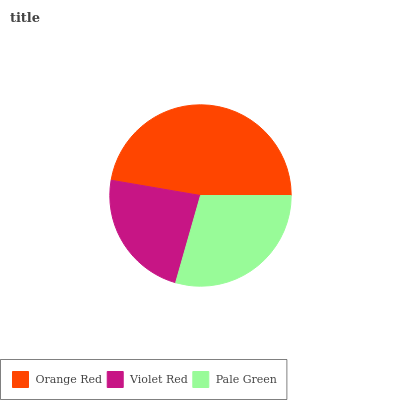Is Violet Red the minimum?
Answer yes or no. Yes. Is Orange Red the maximum?
Answer yes or no. Yes. Is Pale Green the minimum?
Answer yes or no. No. Is Pale Green the maximum?
Answer yes or no. No. Is Pale Green greater than Violet Red?
Answer yes or no. Yes. Is Violet Red less than Pale Green?
Answer yes or no. Yes. Is Violet Red greater than Pale Green?
Answer yes or no. No. Is Pale Green less than Violet Red?
Answer yes or no. No. Is Pale Green the high median?
Answer yes or no. Yes. Is Pale Green the low median?
Answer yes or no. Yes. Is Violet Red the high median?
Answer yes or no. No. Is Violet Red the low median?
Answer yes or no. No. 